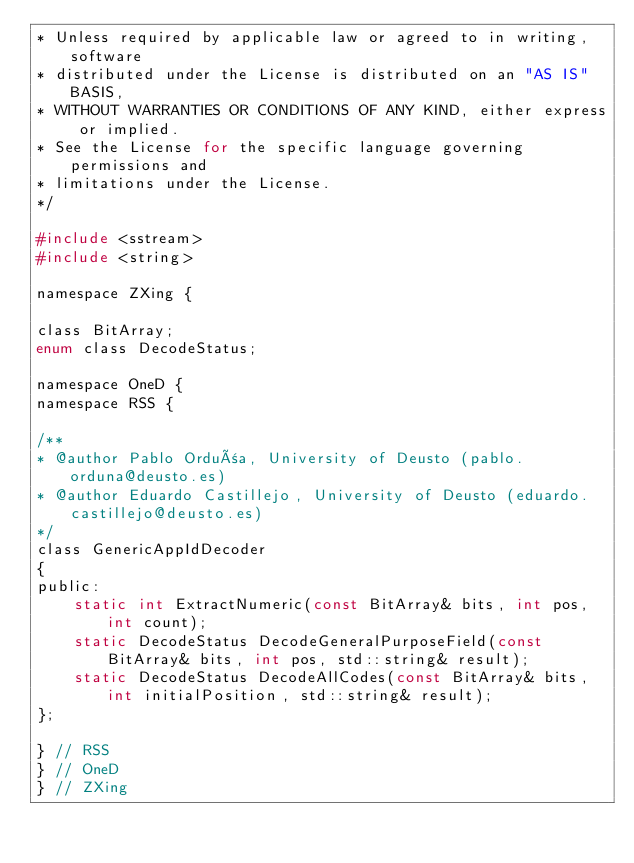<code> <loc_0><loc_0><loc_500><loc_500><_C_>* Unless required by applicable law or agreed to in writing, software
* distributed under the License is distributed on an "AS IS" BASIS,
* WITHOUT WARRANTIES OR CONDITIONS OF ANY KIND, either express or implied.
* See the License for the specific language governing permissions and
* limitations under the License.
*/

#include <sstream>
#include <string>

namespace ZXing {

class BitArray;
enum class DecodeStatus;

namespace OneD {
namespace RSS {

/**
* @author Pablo Orduña, University of Deusto (pablo.orduna@deusto.es)
* @author Eduardo Castillejo, University of Deusto (eduardo.castillejo@deusto.es)
*/
class GenericAppIdDecoder
{
public:
	static int ExtractNumeric(const BitArray& bits, int pos, int count);
	static DecodeStatus DecodeGeneralPurposeField(const BitArray& bits, int pos, std::string& result);
	static DecodeStatus DecodeAllCodes(const BitArray& bits, int initialPosition, std::string& result);
};

} // RSS
} // OneD
} // ZXing
</code> 